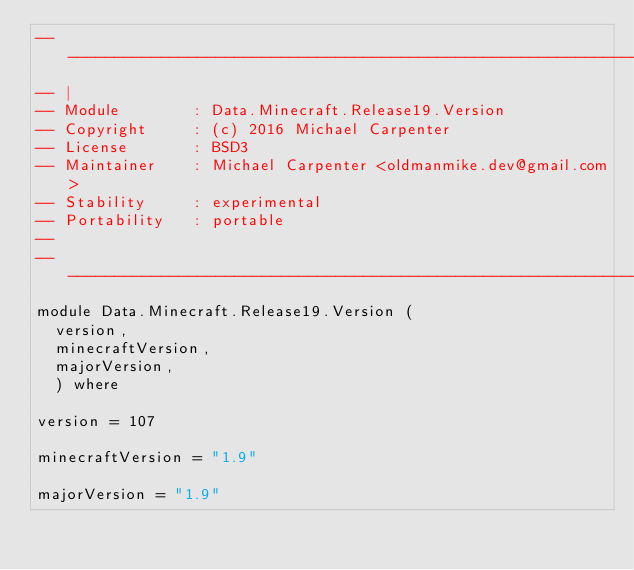Convert code to text. <code><loc_0><loc_0><loc_500><loc_500><_Haskell_>--------------------------------------------------------------------
-- |
-- Module        : Data.Minecraft.Release19.Version
-- Copyright     : (c) 2016 Michael Carpenter
-- License       : BSD3
-- Maintainer    : Michael Carpenter <oldmanmike.dev@gmail.com>
-- Stability     : experimental
-- Portability   : portable
--
--------------------------------------------------------------------
module Data.Minecraft.Release19.Version (
  version,
  minecraftVersion,
  majorVersion,
  ) where

version = 107

minecraftVersion = "1.9"

majorVersion = "1.9"

</code> 